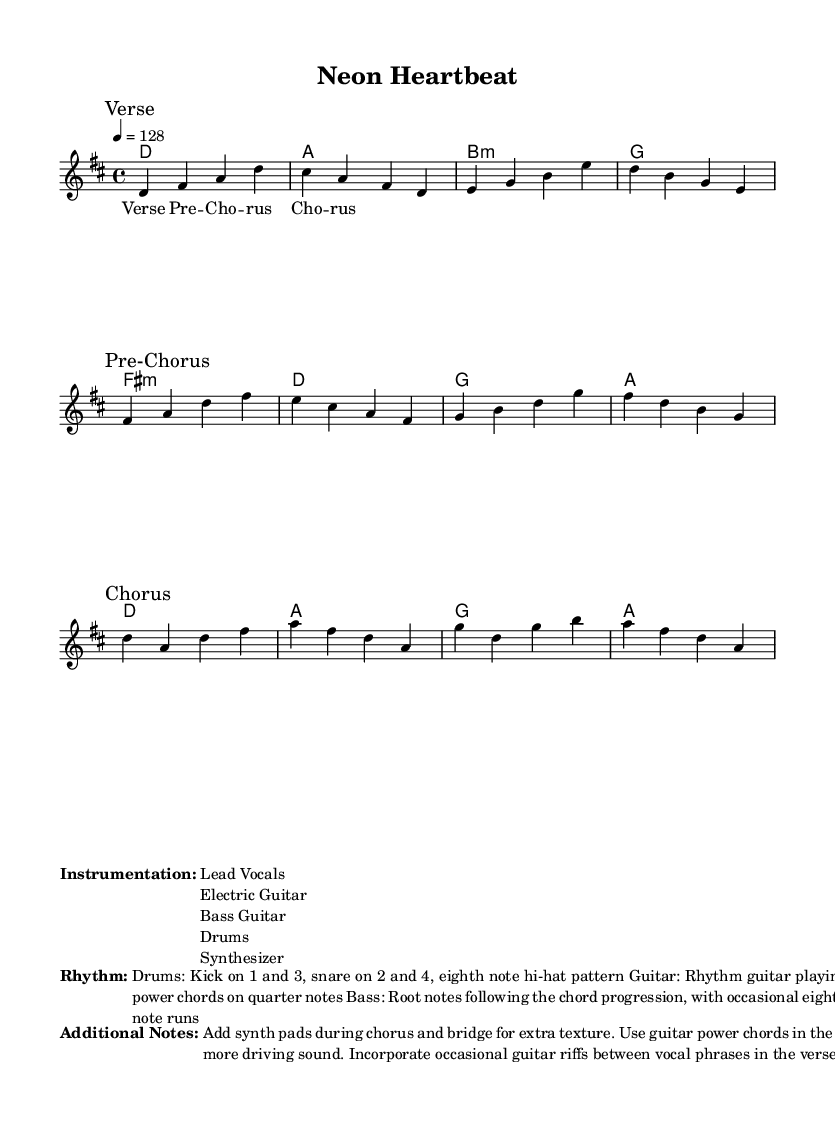What is the key signature of this music? The key signature is indicated by the number of sharps or flats at the beginning of the staff. In this case, D major has two sharps (F# and C#), which can be confirmed by looking for these notes in the music.
Answer: D major What is the time signature of the piece? The time signature is typically found after the key signature at the beginning of the staff. In this instance, the time signature is 4/4, which means there are four beats in each measure and a quarter note receives one beat.
Answer: 4/4 What is the tempo marking for this piece? The tempo is indicated at the beginning of the score, specified as a number of beats per minute. Here, it is marked as "4 = 128," meaning each beat is a quarter note and there are 128 beats per minute.
Answer: 128 How many sections are in the song? The sheet music includes marked sections labeled "Verse," "Pre-Chorus," and "Chorus." Counting these, we find there are three distinct sections in the song.
Answer: Three What is the instrumentation used for this music? The instrumentation is provided in the markup section titled "Instrumentation." It lists the instruments required for the performance: Lead Vocals, Electric Guitar, Bass Guitar, Drums, and Synthesizer.
Answer: Lead Vocals, Electric Guitar, Bass Guitar, Drums, Synthesizer What type of rhythm is used for the drums? The rhythm for the drums is described in the "Rhythm" section. It states that the kick drum plays on beats 1 and 3 and the snare plays on beats 2 and 4 with an eighth note hi-hat pattern, indicating a typical pop rhythm style.
Answer: Kick on 1 and 3, snare on 2 and 4 Which section of the song features additional synth pads? According to the "Additional Notes" section, the synth pads are specifically mentioned to be added during the chorus and bridge for extra texture, highlighting where extra instrumental layers enhance the sound.
Answer: Chorus and bridge 